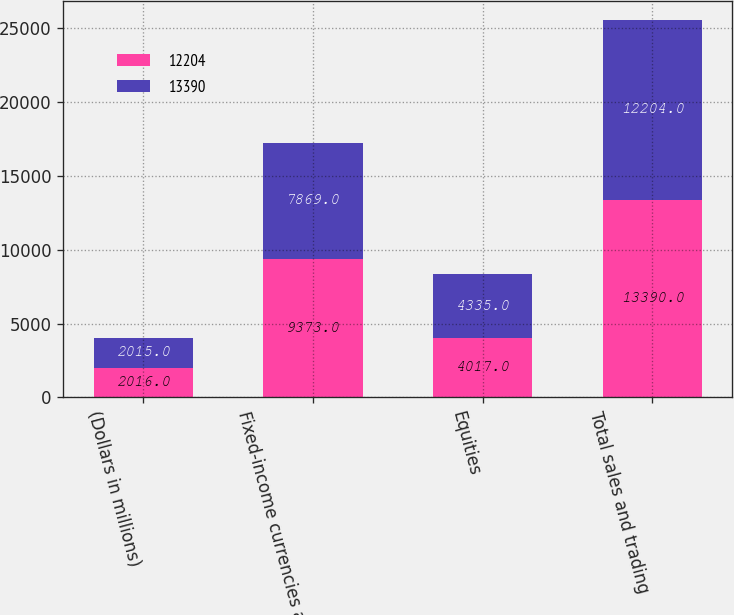<chart> <loc_0><loc_0><loc_500><loc_500><stacked_bar_chart><ecel><fcel>(Dollars in millions)<fcel>Fixed-income currencies and<fcel>Equities<fcel>Total sales and trading<nl><fcel>12204<fcel>2016<fcel>9373<fcel>4017<fcel>13390<nl><fcel>13390<fcel>2015<fcel>7869<fcel>4335<fcel>12204<nl></chart> 